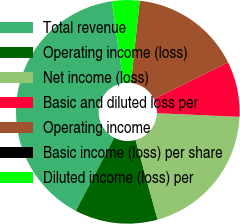<chart> <loc_0><loc_0><loc_500><loc_500><pie_chart><fcel>Total revenue<fcel>Operating income (loss)<fcel>Net income (loss)<fcel>Basic and diluted loss per<fcel>Operating income<fcel>Basic income (loss) per share<fcel>Diluted income (loss) per<nl><fcel>40.0%<fcel>12.0%<fcel>20.0%<fcel>8.0%<fcel>16.0%<fcel>0.0%<fcel>4.0%<nl></chart> 